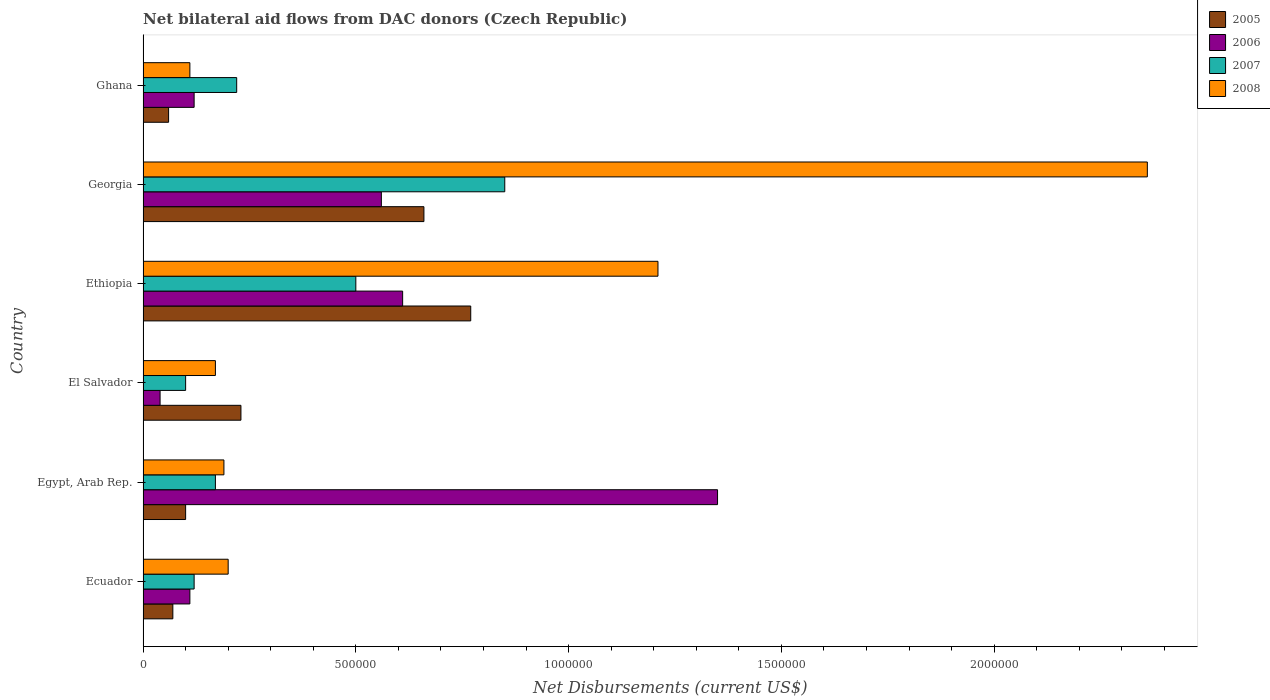How many different coloured bars are there?
Your answer should be compact. 4. How many bars are there on the 4th tick from the bottom?
Make the answer very short. 4. What is the label of the 4th group of bars from the top?
Offer a terse response. El Salvador. In how many cases, is the number of bars for a given country not equal to the number of legend labels?
Give a very brief answer. 0. Across all countries, what is the maximum net bilateral aid flows in 2006?
Your answer should be compact. 1.35e+06. In which country was the net bilateral aid flows in 2006 maximum?
Make the answer very short. Egypt, Arab Rep. What is the total net bilateral aid flows in 2007 in the graph?
Your answer should be very brief. 1.96e+06. What is the difference between the net bilateral aid flows in 2005 in El Salvador and that in Ghana?
Your answer should be compact. 1.70e+05. What is the average net bilateral aid flows in 2005 per country?
Offer a terse response. 3.15e+05. What is the ratio of the net bilateral aid flows in 2007 in Ecuador to that in Ethiopia?
Your answer should be very brief. 0.24. Is the net bilateral aid flows in 2006 in Georgia less than that in Ghana?
Your answer should be very brief. No. Is the difference between the net bilateral aid flows in 2005 in Ecuador and Ghana greater than the difference between the net bilateral aid flows in 2008 in Ecuador and Ghana?
Make the answer very short. No. What is the difference between the highest and the lowest net bilateral aid flows in 2008?
Offer a very short reply. 2.25e+06. What does the 4th bar from the top in El Salvador represents?
Provide a short and direct response. 2005. What does the 3rd bar from the bottom in Ecuador represents?
Give a very brief answer. 2007. Is it the case that in every country, the sum of the net bilateral aid flows in 2007 and net bilateral aid flows in 2005 is greater than the net bilateral aid flows in 2006?
Make the answer very short. No. How many bars are there?
Give a very brief answer. 24. Are all the bars in the graph horizontal?
Offer a very short reply. Yes. How many countries are there in the graph?
Provide a short and direct response. 6. What is the difference between two consecutive major ticks on the X-axis?
Provide a succinct answer. 5.00e+05. Are the values on the major ticks of X-axis written in scientific E-notation?
Keep it short and to the point. No. Where does the legend appear in the graph?
Provide a short and direct response. Top right. How are the legend labels stacked?
Offer a very short reply. Vertical. What is the title of the graph?
Make the answer very short. Net bilateral aid flows from DAC donors (Czech Republic). What is the label or title of the X-axis?
Give a very brief answer. Net Disbursements (current US$). What is the label or title of the Y-axis?
Your answer should be very brief. Country. What is the Net Disbursements (current US$) in 2005 in Ecuador?
Ensure brevity in your answer.  7.00e+04. What is the Net Disbursements (current US$) in 2006 in Egypt, Arab Rep.?
Offer a terse response. 1.35e+06. What is the Net Disbursements (current US$) in 2008 in Egypt, Arab Rep.?
Keep it short and to the point. 1.90e+05. What is the Net Disbursements (current US$) in 2007 in El Salvador?
Your answer should be compact. 1.00e+05. What is the Net Disbursements (current US$) of 2008 in El Salvador?
Ensure brevity in your answer.  1.70e+05. What is the Net Disbursements (current US$) of 2005 in Ethiopia?
Offer a terse response. 7.70e+05. What is the Net Disbursements (current US$) of 2007 in Ethiopia?
Your response must be concise. 5.00e+05. What is the Net Disbursements (current US$) of 2008 in Ethiopia?
Your response must be concise. 1.21e+06. What is the Net Disbursements (current US$) of 2005 in Georgia?
Offer a terse response. 6.60e+05. What is the Net Disbursements (current US$) in 2006 in Georgia?
Ensure brevity in your answer.  5.60e+05. What is the Net Disbursements (current US$) in 2007 in Georgia?
Ensure brevity in your answer.  8.50e+05. What is the Net Disbursements (current US$) of 2008 in Georgia?
Your response must be concise. 2.36e+06. What is the Net Disbursements (current US$) of 2005 in Ghana?
Ensure brevity in your answer.  6.00e+04. What is the Net Disbursements (current US$) of 2006 in Ghana?
Your answer should be very brief. 1.20e+05. What is the Net Disbursements (current US$) of 2008 in Ghana?
Make the answer very short. 1.10e+05. Across all countries, what is the maximum Net Disbursements (current US$) of 2005?
Give a very brief answer. 7.70e+05. Across all countries, what is the maximum Net Disbursements (current US$) of 2006?
Give a very brief answer. 1.35e+06. Across all countries, what is the maximum Net Disbursements (current US$) of 2007?
Your answer should be compact. 8.50e+05. Across all countries, what is the maximum Net Disbursements (current US$) of 2008?
Provide a short and direct response. 2.36e+06. Across all countries, what is the minimum Net Disbursements (current US$) in 2005?
Provide a short and direct response. 6.00e+04. Across all countries, what is the minimum Net Disbursements (current US$) in 2007?
Your answer should be very brief. 1.00e+05. What is the total Net Disbursements (current US$) in 2005 in the graph?
Ensure brevity in your answer.  1.89e+06. What is the total Net Disbursements (current US$) of 2006 in the graph?
Offer a very short reply. 2.79e+06. What is the total Net Disbursements (current US$) in 2007 in the graph?
Keep it short and to the point. 1.96e+06. What is the total Net Disbursements (current US$) of 2008 in the graph?
Make the answer very short. 4.24e+06. What is the difference between the Net Disbursements (current US$) of 2005 in Ecuador and that in Egypt, Arab Rep.?
Your answer should be very brief. -3.00e+04. What is the difference between the Net Disbursements (current US$) in 2006 in Ecuador and that in Egypt, Arab Rep.?
Your answer should be compact. -1.24e+06. What is the difference between the Net Disbursements (current US$) of 2007 in Ecuador and that in Egypt, Arab Rep.?
Your response must be concise. -5.00e+04. What is the difference between the Net Disbursements (current US$) of 2008 in Ecuador and that in Egypt, Arab Rep.?
Keep it short and to the point. 10000. What is the difference between the Net Disbursements (current US$) of 2005 in Ecuador and that in El Salvador?
Offer a terse response. -1.60e+05. What is the difference between the Net Disbursements (current US$) in 2006 in Ecuador and that in El Salvador?
Your answer should be compact. 7.00e+04. What is the difference between the Net Disbursements (current US$) of 2005 in Ecuador and that in Ethiopia?
Make the answer very short. -7.00e+05. What is the difference between the Net Disbursements (current US$) in 2006 in Ecuador and that in Ethiopia?
Provide a succinct answer. -5.00e+05. What is the difference between the Net Disbursements (current US$) in 2007 in Ecuador and that in Ethiopia?
Offer a terse response. -3.80e+05. What is the difference between the Net Disbursements (current US$) of 2008 in Ecuador and that in Ethiopia?
Provide a short and direct response. -1.01e+06. What is the difference between the Net Disbursements (current US$) of 2005 in Ecuador and that in Georgia?
Make the answer very short. -5.90e+05. What is the difference between the Net Disbursements (current US$) in 2006 in Ecuador and that in Georgia?
Offer a terse response. -4.50e+05. What is the difference between the Net Disbursements (current US$) in 2007 in Ecuador and that in Georgia?
Offer a terse response. -7.30e+05. What is the difference between the Net Disbursements (current US$) in 2008 in Ecuador and that in Georgia?
Give a very brief answer. -2.16e+06. What is the difference between the Net Disbursements (current US$) of 2006 in Ecuador and that in Ghana?
Provide a short and direct response. -10000. What is the difference between the Net Disbursements (current US$) of 2007 in Ecuador and that in Ghana?
Provide a short and direct response. -1.00e+05. What is the difference between the Net Disbursements (current US$) in 2006 in Egypt, Arab Rep. and that in El Salvador?
Offer a terse response. 1.31e+06. What is the difference between the Net Disbursements (current US$) in 2008 in Egypt, Arab Rep. and that in El Salvador?
Offer a very short reply. 2.00e+04. What is the difference between the Net Disbursements (current US$) of 2005 in Egypt, Arab Rep. and that in Ethiopia?
Offer a terse response. -6.70e+05. What is the difference between the Net Disbursements (current US$) of 2006 in Egypt, Arab Rep. and that in Ethiopia?
Keep it short and to the point. 7.40e+05. What is the difference between the Net Disbursements (current US$) of 2007 in Egypt, Arab Rep. and that in Ethiopia?
Make the answer very short. -3.30e+05. What is the difference between the Net Disbursements (current US$) of 2008 in Egypt, Arab Rep. and that in Ethiopia?
Offer a very short reply. -1.02e+06. What is the difference between the Net Disbursements (current US$) in 2005 in Egypt, Arab Rep. and that in Georgia?
Offer a very short reply. -5.60e+05. What is the difference between the Net Disbursements (current US$) in 2006 in Egypt, Arab Rep. and that in Georgia?
Ensure brevity in your answer.  7.90e+05. What is the difference between the Net Disbursements (current US$) of 2007 in Egypt, Arab Rep. and that in Georgia?
Give a very brief answer. -6.80e+05. What is the difference between the Net Disbursements (current US$) of 2008 in Egypt, Arab Rep. and that in Georgia?
Keep it short and to the point. -2.17e+06. What is the difference between the Net Disbursements (current US$) of 2005 in Egypt, Arab Rep. and that in Ghana?
Your answer should be very brief. 4.00e+04. What is the difference between the Net Disbursements (current US$) of 2006 in Egypt, Arab Rep. and that in Ghana?
Make the answer very short. 1.23e+06. What is the difference between the Net Disbursements (current US$) in 2007 in Egypt, Arab Rep. and that in Ghana?
Give a very brief answer. -5.00e+04. What is the difference between the Net Disbursements (current US$) of 2008 in Egypt, Arab Rep. and that in Ghana?
Provide a short and direct response. 8.00e+04. What is the difference between the Net Disbursements (current US$) of 2005 in El Salvador and that in Ethiopia?
Your response must be concise. -5.40e+05. What is the difference between the Net Disbursements (current US$) of 2006 in El Salvador and that in Ethiopia?
Give a very brief answer. -5.70e+05. What is the difference between the Net Disbursements (current US$) in 2007 in El Salvador and that in Ethiopia?
Your answer should be very brief. -4.00e+05. What is the difference between the Net Disbursements (current US$) of 2008 in El Salvador and that in Ethiopia?
Make the answer very short. -1.04e+06. What is the difference between the Net Disbursements (current US$) of 2005 in El Salvador and that in Georgia?
Your response must be concise. -4.30e+05. What is the difference between the Net Disbursements (current US$) of 2006 in El Salvador and that in Georgia?
Provide a short and direct response. -5.20e+05. What is the difference between the Net Disbursements (current US$) of 2007 in El Salvador and that in Georgia?
Make the answer very short. -7.50e+05. What is the difference between the Net Disbursements (current US$) in 2008 in El Salvador and that in Georgia?
Offer a terse response. -2.19e+06. What is the difference between the Net Disbursements (current US$) in 2006 in El Salvador and that in Ghana?
Keep it short and to the point. -8.00e+04. What is the difference between the Net Disbursements (current US$) in 2006 in Ethiopia and that in Georgia?
Make the answer very short. 5.00e+04. What is the difference between the Net Disbursements (current US$) in 2007 in Ethiopia and that in Georgia?
Your response must be concise. -3.50e+05. What is the difference between the Net Disbursements (current US$) of 2008 in Ethiopia and that in Georgia?
Provide a short and direct response. -1.15e+06. What is the difference between the Net Disbursements (current US$) of 2005 in Ethiopia and that in Ghana?
Offer a very short reply. 7.10e+05. What is the difference between the Net Disbursements (current US$) of 2006 in Ethiopia and that in Ghana?
Provide a succinct answer. 4.90e+05. What is the difference between the Net Disbursements (current US$) in 2007 in Ethiopia and that in Ghana?
Your response must be concise. 2.80e+05. What is the difference between the Net Disbursements (current US$) in 2008 in Ethiopia and that in Ghana?
Provide a short and direct response. 1.10e+06. What is the difference between the Net Disbursements (current US$) of 2005 in Georgia and that in Ghana?
Your answer should be very brief. 6.00e+05. What is the difference between the Net Disbursements (current US$) in 2006 in Georgia and that in Ghana?
Ensure brevity in your answer.  4.40e+05. What is the difference between the Net Disbursements (current US$) in 2007 in Georgia and that in Ghana?
Make the answer very short. 6.30e+05. What is the difference between the Net Disbursements (current US$) of 2008 in Georgia and that in Ghana?
Offer a very short reply. 2.25e+06. What is the difference between the Net Disbursements (current US$) of 2005 in Ecuador and the Net Disbursements (current US$) of 2006 in Egypt, Arab Rep.?
Your answer should be compact. -1.28e+06. What is the difference between the Net Disbursements (current US$) in 2005 in Ecuador and the Net Disbursements (current US$) in 2007 in Egypt, Arab Rep.?
Give a very brief answer. -1.00e+05. What is the difference between the Net Disbursements (current US$) of 2005 in Ecuador and the Net Disbursements (current US$) of 2008 in Egypt, Arab Rep.?
Offer a very short reply. -1.20e+05. What is the difference between the Net Disbursements (current US$) in 2006 in Ecuador and the Net Disbursements (current US$) in 2007 in Egypt, Arab Rep.?
Offer a terse response. -6.00e+04. What is the difference between the Net Disbursements (current US$) of 2007 in Ecuador and the Net Disbursements (current US$) of 2008 in Egypt, Arab Rep.?
Offer a very short reply. -7.00e+04. What is the difference between the Net Disbursements (current US$) in 2005 in Ecuador and the Net Disbursements (current US$) in 2006 in El Salvador?
Provide a succinct answer. 3.00e+04. What is the difference between the Net Disbursements (current US$) of 2005 in Ecuador and the Net Disbursements (current US$) of 2007 in El Salvador?
Your answer should be very brief. -3.00e+04. What is the difference between the Net Disbursements (current US$) in 2005 in Ecuador and the Net Disbursements (current US$) in 2008 in El Salvador?
Offer a very short reply. -1.00e+05. What is the difference between the Net Disbursements (current US$) of 2006 in Ecuador and the Net Disbursements (current US$) of 2007 in El Salvador?
Provide a succinct answer. 10000. What is the difference between the Net Disbursements (current US$) of 2006 in Ecuador and the Net Disbursements (current US$) of 2008 in El Salvador?
Offer a very short reply. -6.00e+04. What is the difference between the Net Disbursements (current US$) of 2005 in Ecuador and the Net Disbursements (current US$) of 2006 in Ethiopia?
Your response must be concise. -5.40e+05. What is the difference between the Net Disbursements (current US$) in 2005 in Ecuador and the Net Disbursements (current US$) in 2007 in Ethiopia?
Your response must be concise. -4.30e+05. What is the difference between the Net Disbursements (current US$) in 2005 in Ecuador and the Net Disbursements (current US$) in 2008 in Ethiopia?
Your answer should be very brief. -1.14e+06. What is the difference between the Net Disbursements (current US$) in 2006 in Ecuador and the Net Disbursements (current US$) in 2007 in Ethiopia?
Provide a succinct answer. -3.90e+05. What is the difference between the Net Disbursements (current US$) of 2006 in Ecuador and the Net Disbursements (current US$) of 2008 in Ethiopia?
Make the answer very short. -1.10e+06. What is the difference between the Net Disbursements (current US$) of 2007 in Ecuador and the Net Disbursements (current US$) of 2008 in Ethiopia?
Provide a succinct answer. -1.09e+06. What is the difference between the Net Disbursements (current US$) in 2005 in Ecuador and the Net Disbursements (current US$) in 2006 in Georgia?
Keep it short and to the point. -4.90e+05. What is the difference between the Net Disbursements (current US$) in 2005 in Ecuador and the Net Disbursements (current US$) in 2007 in Georgia?
Provide a short and direct response. -7.80e+05. What is the difference between the Net Disbursements (current US$) in 2005 in Ecuador and the Net Disbursements (current US$) in 2008 in Georgia?
Ensure brevity in your answer.  -2.29e+06. What is the difference between the Net Disbursements (current US$) in 2006 in Ecuador and the Net Disbursements (current US$) in 2007 in Georgia?
Provide a short and direct response. -7.40e+05. What is the difference between the Net Disbursements (current US$) of 2006 in Ecuador and the Net Disbursements (current US$) of 2008 in Georgia?
Provide a short and direct response. -2.25e+06. What is the difference between the Net Disbursements (current US$) of 2007 in Ecuador and the Net Disbursements (current US$) of 2008 in Georgia?
Make the answer very short. -2.24e+06. What is the difference between the Net Disbursements (current US$) in 2005 in Ecuador and the Net Disbursements (current US$) in 2006 in Ghana?
Your answer should be very brief. -5.00e+04. What is the difference between the Net Disbursements (current US$) in 2006 in Ecuador and the Net Disbursements (current US$) in 2008 in Ghana?
Your answer should be compact. 0. What is the difference between the Net Disbursements (current US$) of 2005 in Egypt, Arab Rep. and the Net Disbursements (current US$) of 2006 in El Salvador?
Keep it short and to the point. 6.00e+04. What is the difference between the Net Disbursements (current US$) of 2006 in Egypt, Arab Rep. and the Net Disbursements (current US$) of 2007 in El Salvador?
Provide a succinct answer. 1.25e+06. What is the difference between the Net Disbursements (current US$) in 2006 in Egypt, Arab Rep. and the Net Disbursements (current US$) in 2008 in El Salvador?
Give a very brief answer. 1.18e+06. What is the difference between the Net Disbursements (current US$) in 2007 in Egypt, Arab Rep. and the Net Disbursements (current US$) in 2008 in El Salvador?
Provide a succinct answer. 0. What is the difference between the Net Disbursements (current US$) of 2005 in Egypt, Arab Rep. and the Net Disbursements (current US$) of 2006 in Ethiopia?
Ensure brevity in your answer.  -5.10e+05. What is the difference between the Net Disbursements (current US$) in 2005 in Egypt, Arab Rep. and the Net Disbursements (current US$) in 2007 in Ethiopia?
Provide a succinct answer. -4.00e+05. What is the difference between the Net Disbursements (current US$) in 2005 in Egypt, Arab Rep. and the Net Disbursements (current US$) in 2008 in Ethiopia?
Provide a short and direct response. -1.11e+06. What is the difference between the Net Disbursements (current US$) of 2006 in Egypt, Arab Rep. and the Net Disbursements (current US$) of 2007 in Ethiopia?
Your answer should be very brief. 8.50e+05. What is the difference between the Net Disbursements (current US$) in 2006 in Egypt, Arab Rep. and the Net Disbursements (current US$) in 2008 in Ethiopia?
Provide a succinct answer. 1.40e+05. What is the difference between the Net Disbursements (current US$) of 2007 in Egypt, Arab Rep. and the Net Disbursements (current US$) of 2008 in Ethiopia?
Ensure brevity in your answer.  -1.04e+06. What is the difference between the Net Disbursements (current US$) in 2005 in Egypt, Arab Rep. and the Net Disbursements (current US$) in 2006 in Georgia?
Your answer should be compact. -4.60e+05. What is the difference between the Net Disbursements (current US$) of 2005 in Egypt, Arab Rep. and the Net Disbursements (current US$) of 2007 in Georgia?
Provide a succinct answer. -7.50e+05. What is the difference between the Net Disbursements (current US$) of 2005 in Egypt, Arab Rep. and the Net Disbursements (current US$) of 2008 in Georgia?
Offer a terse response. -2.26e+06. What is the difference between the Net Disbursements (current US$) of 2006 in Egypt, Arab Rep. and the Net Disbursements (current US$) of 2008 in Georgia?
Give a very brief answer. -1.01e+06. What is the difference between the Net Disbursements (current US$) in 2007 in Egypt, Arab Rep. and the Net Disbursements (current US$) in 2008 in Georgia?
Offer a very short reply. -2.19e+06. What is the difference between the Net Disbursements (current US$) in 2005 in Egypt, Arab Rep. and the Net Disbursements (current US$) in 2007 in Ghana?
Ensure brevity in your answer.  -1.20e+05. What is the difference between the Net Disbursements (current US$) of 2006 in Egypt, Arab Rep. and the Net Disbursements (current US$) of 2007 in Ghana?
Your answer should be very brief. 1.13e+06. What is the difference between the Net Disbursements (current US$) in 2006 in Egypt, Arab Rep. and the Net Disbursements (current US$) in 2008 in Ghana?
Offer a very short reply. 1.24e+06. What is the difference between the Net Disbursements (current US$) of 2007 in Egypt, Arab Rep. and the Net Disbursements (current US$) of 2008 in Ghana?
Provide a succinct answer. 6.00e+04. What is the difference between the Net Disbursements (current US$) of 2005 in El Salvador and the Net Disbursements (current US$) of 2006 in Ethiopia?
Provide a succinct answer. -3.80e+05. What is the difference between the Net Disbursements (current US$) of 2005 in El Salvador and the Net Disbursements (current US$) of 2007 in Ethiopia?
Provide a short and direct response. -2.70e+05. What is the difference between the Net Disbursements (current US$) of 2005 in El Salvador and the Net Disbursements (current US$) of 2008 in Ethiopia?
Ensure brevity in your answer.  -9.80e+05. What is the difference between the Net Disbursements (current US$) of 2006 in El Salvador and the Net Disbursements (current US$) of 2007 in Ethiopia?
Offer a terse response. -4.60e+05. What is the difference between the Net Disbursements (current US$) of 2006 in El Salvador and the Net Disbursements (current US$) of 2008 in Ethiopia?
Your answer should be very brief. -1.17e+06. What is the difference between the Net Disbursements (current US$) of 2007 in El Salvador and the Net Disbursements (current US$) of 2008 in Ethiopia?
Give a very brief answer. -1.11e+06. What is the difference between the Net Disbursements (current US$) in 2005 in El Salvador and the Net Disbursements (current US$) in 2006 in Georgia?
Give a very brief answer. -3.30e+05. What is the difference between the Net Disbursements (current US$) in 2005 in El Salvador and the Net Disbursements (current US$) in 2007 in Georgia?
Offer a very short reply. -6.20e+05. What is the difference between the Net Disbursements (current US$) of 2005 in El Salvador and the Net Disbursements (current US$) of 2008 in Georgia?
Your answer should be compact. -2.13e+06. What is the difference between the Net Disbursements (current US$) of 2006 in El Salvador and the Net Disbursements (current US$) of 2007 in Georgia?
Your answer should be very brief. -8.10e+05. What is the difference between the Net Disbursements (current US$) in 2006 in El Salvador and the Net Disbursements (current US$) in 2008 in Georgia?
Your answer should be very brief. -2.32e+06. What is the difference between the Net Disbursements (current US$) in 2007 in El Salvador and the Net Disbursements (current US$) in 2008 in Georgia?
Ensure brevity in your answer.  -2.26e+06. What is the difference between the Net Disbursements (current US$) in 2005 in Ethiopia and the Net Disbursements (current US$) in 2007 in Georgia?
Give a very brief answer. -8.00e+04. What is the difference between the Net Disbursements (current US$) in 2005 in Ethiopia and the Net Disbursements (current US$) in 2008 in Georgia?
Offer a terse response. -1.59e+06. What is the difference between the Net Disbursements (current US$) in 2006 in Ethiopia and the Net Disbursements (current US$) in 2007 in Georgia?
Your answer should be compact. -2.40e+05. What is the difference between the Net Disbursements (current US$) of 2006 in Ethiopia and the Net Disbursements (current US$) of 2008 in Georgia?
Provide a succinct answer. -1.75e+06. What is the difference between the Net Disbursements (current US$) of 2007 in Ethiopia and the Net Disbursements (current US$) of 2008 in Georgia?
Give a very brief answer. -1.86e+06. What is the difference between the Net Disbursements (current US$) in 2005 in Ethiopia and the Net Disbursements (current US$) in 2006 in Ghana?
Provide a succinct answer. 6.50e+05. What is the difference between the Net Disbursements (current US$) of 2005 in Ethiopia and the Net Disbursements (current US$) of 2007 in Ghana?
Ensure brevity in your answer.  5.50e+05. What is the difference between the Net Disbursements (current US$) of 2005 in Ethiopia and the Net Disbursements (current US$) of 2008 in Ghana?
Ensure brevity in your answer.  6.60e+05. What is the difference between the Net Disbursements (current US$) in 2006 in Ethiopia and the Net Disbursements (current US$) in 2007 in Ghana?
Offer a terse response. 3.90e+05. What is the difference between the Net Disbursements (current US$) of 2006 in Ethiopia and the Net Disbursements (current US$) of 2008 in Ghana?
Provide a succinct answer. 5.00e+05. What is the difference between the Net Disbursements (current US$) in 2007 in Ethiopia and the Net Disbursements (current US$) in 2008 in Ghana?
Your answer should be very brief. 3.90e+05. What is the difference between the Net Disbursements (current US$) of 2005 in Georgia and the Net Disbursements (current US$) of 2006 in Ghana?
Give a very brief answer. 5.40e+05. What is the difference between the Net Disbursements (current US$) in 2005 in Georgia and the Net Disbursements (current US$) in 2007 in Ghana?
Offer a very short reply. 4.40e+05. What is the difference between the Net Disbursements (current US$) in 2005 in Georgia and the Net Disbursements (current US$) in 2008 in Ghana?
Offer a very short reply. 5.50e+05. What is the difference between the Net Disbursements (current US$) of 2007 in Georgia and the Net Disbursements (current US$) of 2008 in Ghana?
Your response must be concise. 7.40e+05. What is the average Net Disbursements (current US$) in 2005 per country?
Offer a terse response. 3.15e+05. What is the average Net Disbursements (current US$) of 2006 per country?
Provide a succinct answer. 4.65e+05. What is the average Net Disbursements (current US$) in 2007 per country?
Provide a succinct answer. 3.27e+05. What is the average Net Disbursements (current US$) in 2008 per country?
Your answer should be very brief. 7.07e+05. What is the difference between the Net Disbursements (current US$) of 2005 and Net Disbursements (current US$) of 2006 in Ecuador?
Keep it short and to the point. -4.00e+04. What is the difference between the Net Disbursements (current US$) in 2005 and Net Disbursements (current US$) in 2006 in Egypt, Arab Rep.?
Give a very brief answer. -1.25e+06. What is the difference between the Net Disbursements (current US$) of 2005 and Net Disbursements (current US$) of 2008 in Egypt, Arab Rep.?
Offer a very short reply. -9.00e+04. What is the difference between the Net Disbursements (current US$) in 2006 and Net Disbursements (current US$) in 2007 in Egypt, Arab Rep.?
Offer a very short reply. 1.18e+06. What is the difference between the Net Disbursements (current US$) in 2006 and Net Disbursements (current US$) in 2008 in Egypt, Arab Rep.?
Provide a short and direct response. 1.16e+06. What is the difference between the Net Disbursements (current US$) of 2005 and Net Disbursements (current US$) of 2008 in El Salvador?
Your answer should be compact. 6.00e+04. What is the difference between the Net Disbursements (current US$) of 2007 and Net Disbursements (current US$) of 2008 in El Salvador?
Make the answer very short. -7.00e+04. What is the difference between the Net Disbursements (current US$) in 2005 and Net Disbursements (current US$) in 2008 in Ethiopia?
Ensure brevity in your answer.  -4.40e+05. What is the difference between the Net Disbursements (current US$) of 2006 and Net Disbursements (current US$) of 2008 in Ethiopia?
Offer a very short reply. -6.00e+05. What is the difference between the Net Disbursements (current US$) of 2007 and Net Disbursements (current US$) of 2008 in Ethiopia?
Offer a terse response. -7.10e+05. What is the difference between the Net Disbursements (current US$) in 2005 and Net Disbursements (current US$) in 2008 in Georgia?
Ensure brevity in your answer.  -1.70e+06. What is the difference between the Net Disbursements (current US$) of 2006 and Net Disbursements (current US$) of 2007 in Georgia?
Provide a short and direct response. -2.90e+05. What is the difference between the Net Disbursements (current US$) of 2006 and Net Disbursements (current US$) of 2008 in Georgia?
Your response must be concise. -1.80e+06. What is the difference between the Net Disbursements (current US$) in 2007 and Net Disbursements (current US$) in 2008 in Georgia?
Offer a very short reply. -1.51e+06. What is the difference between the Net Disbursements (current US$) in 2006 and Net Disbursements (current US$) in 2008 in Ghana?
Make the answer very short. 10000. What is the difference between the Net Disbursements (current US$) of 2007 and Net Disbursements (current US$) of 2008 in Ghana?
Provide a succinct answer. 1.10e+05. What is the ratio of the Net Disbursements (current US$) in 2005 in Ecuador to that in Egypt, Arab Rep.?
Your answer should be compact. 0.7. What is the ratio of the Net Disbursements (current US$) in 2006 in Ecuador to that in Egypt, Arab Rep.?
Provide a succinct answer. 0.08. What is the ratio of the Net Disbursements (current US$) of 2007 in Ecuador to that in Egypt, Arab Rep.?
Provide a succinct answer. 0.71. What is the ratio of the Net Disbursements (current US$) of 2008 in Ecuador to that in Egypt, Arab Rep.?
Make the answer very short. 1.05. What is the ratio of the Net Disbursements (current US$) of 2005 in Ecuador to that in El Salvador?
Give a very brief answer. 0.3. What is the ratio of the Net Disbursements (current US$) of 2006 in Ecuador to that in El Salvador?
Provide a short and direct response. 2.75. What is the ratio of the Net Disbursements (current US$) of 2007 in Ecuador to that in El Salvador?
Offer a terse response. 1.2. What is the ratio of the Net Disbursements (current US$) in 2008 in Ecuador to that in El Salvador?
Offer a terse response. 1.18. What is the ratio of the Net Disbursements (current US$) in 2005 in Ecuador to that in Ethiopia?
Offer a terse response. 0.09. What is the ratio of the Net Disbursements (current US$) of 2006 in Ecuador to that in Ethiopia?
Provide a short and direct response. 0.18. What is the ratio of the Net Disbursements (current US$) of 2007 in Ecuador to that in Ethiopia?
Provide a short and direct response. 0.24. What is the ratio of the Net Disbursements (current US$) of 2008 in Ecuador to that in Ethiopia?
Ensure brevity in your answer.  0.17. What is the ratio of the Net Disbursements (current US$) in 2005 in Ecuador to that in Georgia?
Your response must be concise. 0.11. What is the ratio of the Net Disbursements (current US$) in 2006 in Ecuador to that in Georgia?
Your answer should be compact. 0.2. What is the ratio of the Net Disbursements (current US$) of 2007 in Ecuador to that in Georgia?
Provide a short and direct response. 0.14. What is the ratio of the Net Disbursements (current US$) of 2008 in Ecuador to that in Georgia?
Keep it short and to the point. 0.08. What is the ratio of the Net Disbursements (current US$) in 2005 in Ecuador to that in Ghana?
Give a very brief answer. 1.17. What is the ratio of the Net Disbursements (current US$) in 2006 in Ecuador to that in Ghana?
Make the answer very short. 0.92. What is the ratio of the Net Disbursements (current US$) in 2007 in Ecuador to that in Ghana?
Your answer should be compact. 0.55. What is the ratio of the Net Disbursements (current US$) of 2008 in Ecuador to that in Ghana?
Ensure brevity in your answer.  1.82. What is the ratio of the Net Disbursements (current US$) in 2005 in Egypt, Arab Rep. to that in El Salvador?
Ensure brevity in your answer.  0.43. What is the ratio of the Net Disbursements (current US$) in 2006 in Egypt, Arab Rep. to that in El Salvador?
Give a very brief answer. 33.75. What is the ratio of the Net Disbursements (current US$) in 2008 in Egypt, Arab Rep. to that in El Salvador?
Your response must be concise. 1.12. What is the ratio of the Net Disbursements (current US$) in 2005 in Egypt, Arab Rep. to that in Ethiopia?
Your answer should be very brief. 0.13. What is the ratio of the Net Disbursements (current US$) in 2006 in Egypt, Arab Rep. to that in Ethiopia?
Provide a short and direct response. 2.21. What is the ratio of the Net Disbursements (current US$) of 2007 in Egypt, Arab Rep. to that in Ethiopia?
Give a very brief answer. 0.34. What is the ratio of the Net Disbursements (current US$) in 2008 in Egypt, Arab Rep. to that in Ethiopia?
Your response must be concise. 0.16. What is the ratio of the Net Disbursements (current US$) of 2005 in Egypt, Arab Rep. to that in Georgia?
Offer a very short reply. 0.15. What is the ratio of the Net Disbursements (current US$) of 2006 in Egypt, Arab Rep. to that in Georgia?
Your response must be concise. 2.41. What is the ratio of the Net Disbursements (current US$) of 2007 in Egypt, Arab Rep. to that in Georgia?
Give a very brief answer. 0.2. What is the ratio of the Net Disbursements (current US$) in 2008 in Egypt, Arab Rep. to that in Georgia?
Keep it short and to the point. 0.08. What is the ratio of the Net Disbursements (current US$) in 2005 in Egypt, Arab Rep. to that in Ghana?
Provide a short and direct response. 1.67. What is the ratio of the Net Disbursements (current US$) of 2006 in Egypt, Arab Rep. to that in Ghana?
Keep it short and to the point. 11.25. What is the ratio of the Net Disbursements (current US$) of 2007 in Egypt, Arab Rep. to that in Ghana?
Provide a short and direct response. 0.77. What is the ratio of the Net Disbursements (current US$) of 2008 in Egypt, Arab Rep. to that in Ghana?
Provide a short and direct response. 1.73. What is the ratio of the Net Disbursements (current US$) of 2005 in El Salvador to that in Ethiopia?
Your answer should be very brief. 0.3. What is the ratio of the Net Disbursements (current US$) in 2006 in El Salvador to that in Ethiopia?
Your answer should be compact. 0.07. What is the ratio of the Net Disbursements (current US$) of 2007 in El Salvador to that in Ethiopia?
Keep it short and to the point. 0.2. What is the ratio of the Net Disbursements (current US$) in 2008 in El Salvador to that in Ethiopia?
Your answer should be compact. 0.14. What is the ratio of the Net Disbursements (current US$) in 2005 in El Salvador to that in Georgia?
Provide a succinct answer. 0.35. What is the ratio of the Net Disbursements (current US$) in 2006 in El Salvador to that in Georgia?
Your response must be concise. 0.07. What is the ratio of the Net Disbursements (current US$) in 2007 in El Salvador to that in Georgia?
Give a very brief answer. 0.12. What is the ratio of the Net Disbursements (current US$) in 2008 in El Salvador to that in Georgia?
Ensure brevity in your answer.  0.07. What is the ratio of the Net Disbursements (current US$) in 2005 in El Salvador to that in Ghana?
Offer a very short reply. 3.83. What is the ratio of the Net Disbursements (current US$) in 2007 in El Salvador to that in Ghana?
Provide a succinct answer. 0.45. What is the ratio of the Net Disbursements (current US$) of 2008 in El Salvador to that in Ghana?
Give a very brief answer. 1.55. What is the ratio of the Net Disbursements (current US$) in 2005 in Ethiopia to that in Georgia?
Keep it short and to the point. 1.17. What is the ratio of the Net Disbursements (current US$) of 2006 in Ethiopia to that in Georgia?
Give a very brief answer. 1.09. What is the ratio of the Net Disbursements (current US$) of 2007 in Ethiopia to that in Georgia?
Your response must be concise. 0.59. What is the ratio of the Net Disbursements (current US$) in 2008 in Ethiopia to that in Georgia?
Your response must be concise. 0.51. What is the ratio of the Net Disbursements (current US$) in 2005 in Ethiopia to that in Ghana?
Ensure brevity in your answer.  12.83. What is the ratio of the Net Disbursements (current US$) in 2006 in Ethiopia to that in Ghana?
Provide a short and direct response. 5.08. What is the ratio of the Net Disbursements (current US$) of 2007 in Ethiopia to that in Ghana?
Make the answer very short. 2.27. What is the ratio of the Net Disbursements (current US$) in 2006 in Georgia to that in Ghana?
Your response must be concise. 4.67. What is the ratio of the Net Disbursements (current US$) of 2007 in Georgia to that in Ghana?
Your response must be concise. 3.86. What is the ratio of the Net Disbursements (current US$) in 2008 in Georgia to that in Ghana?
Provide a short and direct response. 21.45. What is the difference between the highest and the second highest Net Disbursements (current US$) in 2006?
Give a very brief answer. 7.40e+05. What is the difference between the highest and the second highest Net Disbursements (current US$) in 2008?
Your response must be concise. 1.15e+06. What is the difference between the highest and the lowest Net Disbursements (current US$) in 2005?
Make the answer very short. 7.10e+05. What is the difference between the highest and the lowest Net Disbursements (current US$) in 2006?
Keep it short and to the point. 1.31e+06. What is the difference between the highest and the lowest Net Disbursements (current US$) in 2007?
Your answer should be compact. 7.50e+05. What is the difference between the highest and the lowest Net Disbursements (current US$) of 2008?
Your response must be concise. 2.25e+06. 